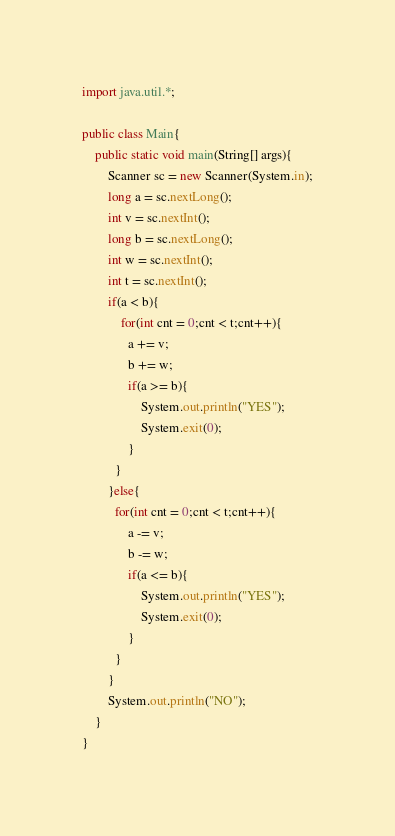Convert code to text. <code><loc_0><loc_0><loc_500><loc_500><_Java_>import java.util.*;

public class Main{
	public static void main(String[] args){
      	Scanner sc = new Scanner(System.in);
    	long a = sc.nextLong();
      	int v = sc.nextInt();
      	long b = sc.nextLong();
      	int w = sc.nextInt();
      	int t = sc.nextInt();
      	if(a < b){
        	for(int cnt = 0;cnt < t;cnt++){
              a += v;
              b += w;
              if(a >= b){
                  System.out.println("YES");
                  System.exit(0);
              }
          }
        }else{
          for(int cnt = 0;cnt < t;cnt++){
              a -= v;
              b -= w;
              if(a <= b){
                  System.out.println("YES");
                  System.exit(0);
              }
          }
        }
      	System.out.println("NO");
    }
}</code> 